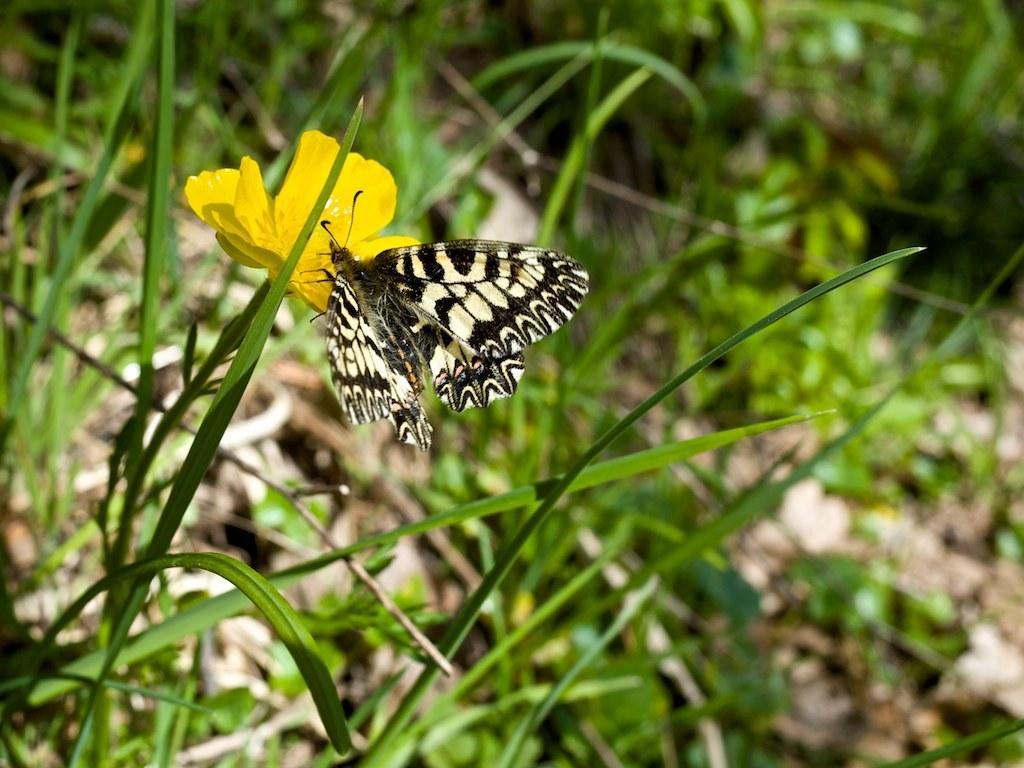How would you summarize this image in a sentence or two? In the foreground of this image, there is a cream and black colored butterfly on a yellow colored flower. In the background, we see grass and plants. 